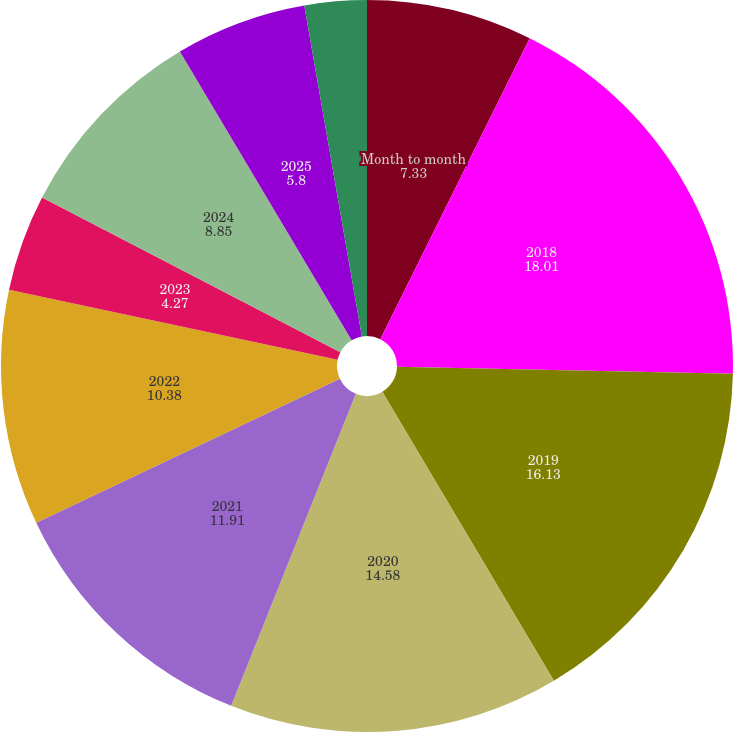Convert chart. <chart><loc_0><loc_0><loc_500><loc_500><pie_chart><fcel>Month to month<fcel>2018<fcel>2019<fcel>2020<fcel>2021<fcel>2022<fcel>2023<fcel>2024<fcel>2025<fcel>2026<nl><fcel>7.33%<fcel>18.01%<fcel>16.13%<fcel>14.58%<fcel>11.91%<fcel>10.38%<fcel>4.27%<fcel>8.85%<fcel>5.8%<fcel>2.74%<nl></chart> 